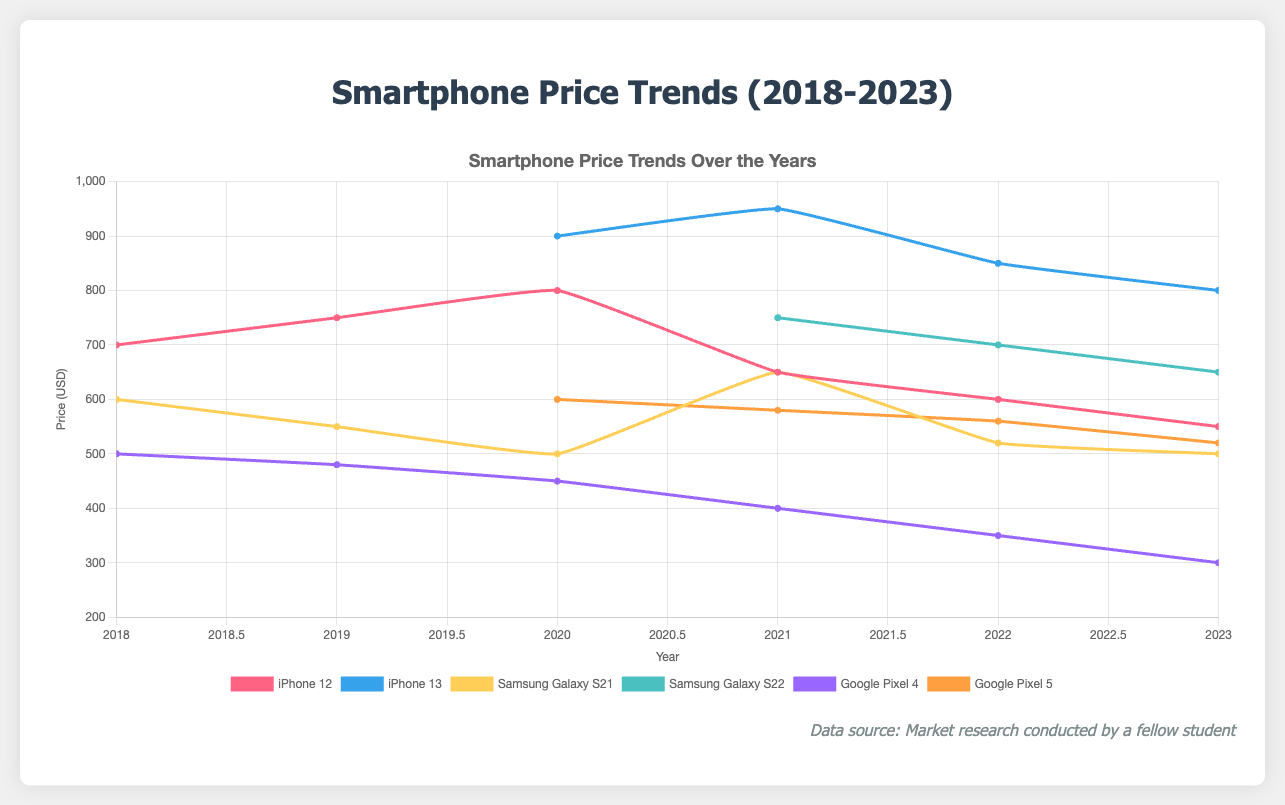What is the price trend for the iPhone 12 from 2018 to 2023? The price of the iPhone 12 starts at $700 in 2018, increases to $750 in 2019, peaks at $800 in 2020, then decreases to $650 in 2021, $600 in 2022, and finally $550 in 2023.
Answer: Decreasing trend overall from $700 to $550 Which smartphone had the lowest price in 2023? By examining the endpoints of the lines, we see that the Google Pixel 4 had the lowest price at $300 in 2023.
Answer: Google Pixel 4 How do the price trends for the Samsung Galaxy S21 and Google Pixel 4 compare from 2020 to 2023? In 2020, the Samsung Galaxy S21 starts at $500 and the Google Pixel 4 at $450. By 2023, the S21 remains at $500 while the Pixel 4 drops to $300. The S21 sees fluctuations, but the Pixel 4 consistently decreases.
Answer: S21 fluctuates, Pixel 4 consistently decreases What is the average price of the iPhone 13 over the years it was released? Summing up the prices (900 in 2020, 950 in 2021, 850 in 2022, 800 in 2023) gives 3500. Dividing by the number of years (4) results in an average price of $875.
Answer: $875 Which brand shows more price stability, Apple or Samsung, based on the given data? Comparing Apple (iPhone 12, 13) and Samsung (Galaxy S21, S22), Samsung shows more stability with less drastic changes, especially the Galaxy S22 having a consistent downward trend (750 to 650).
Answer: Samsung Which product saw the steepest price drop from its initial release to 2023? Comparing price differences: iPhone 12 ($700 to $550, drop $150), Samsung Galaxy S21 ($600 to $500, drop $100), Google Pixel 4 ($500 to $300, drop $200). The Google Pixel 4 had the steepest drop.
Answer: Google Pixel 4 What is the main difference in price trends between Google Pixel 5 and iPhone 12 from 2020 to 2023? The Pixel 5 starts at $600 in 2020 and drops to $520 by 2023 (steady decline). The iPhone 12 starts at $800 in 2020 and drops to $550 by 2023 (sharp drop).
Answer: iPhone 12 has sharper declines Among the products listed, which model experienced a price increase at any point in time? The Samsung Galaxy S21 increased from $500 in 2020 to $650 in 2021 before dropping again.
Answer: Samsung Galaxy S21 Considering the trends, which model would be predicted to have the largest price drop by 2024 if the current trend continues? Based on the consistent steep declines of the Google Pixel 4 dropping by $200 over 5 years, this would likely continue at the same rate.
Answer: Google Pixel 4 